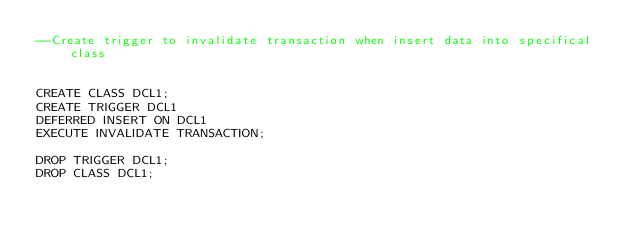Convert code to text. <code><loc_0><loc_0><loc_500><loc_500><_SQL_>--Create trigger to invalidate transaction when insert data into specifical class


CREATE CLASS DCL1;	
CREATE TRIGGER DCL1	
DEFERRED INSERT ON DCL1	
EXECUTE INVALIDATE TRANSACTION;	

DROP TRIGGER DCL1;
DROP CLASS DCL1;	
</code> 